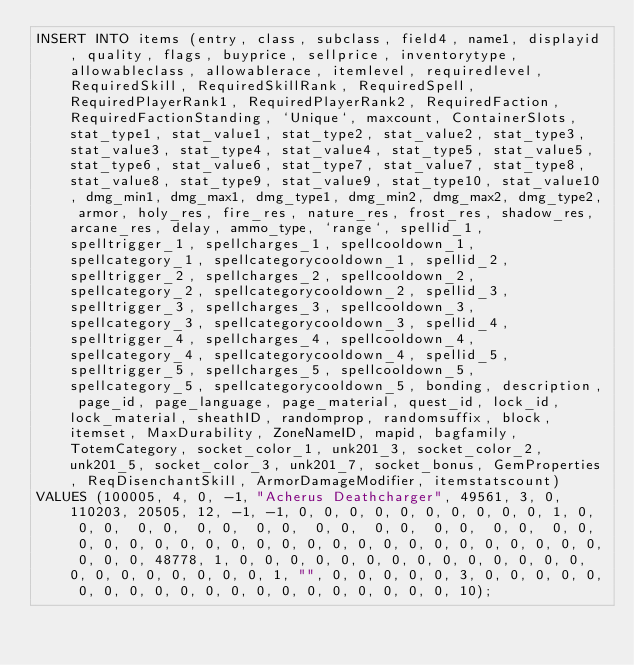<code> <loc_0><loc_0><loc_500><loc_500><_SQL_>INSERT INTO items (entry, class, subclass, field4, name1, displayid, quality, flags, buyprice, sellprice, inventorytype, allowableclass, allowablerace, itemlevel, requiredlevel, RequiredSkill, RequiredSkillRank, RequiredSpell, RequiredPlayerRank1, RequiredPlayerRank2, RequiredFaction, RequiredFactionStanding, `Unique`, maxcount, ContainerSlots, stat_type1, stat_value1, stat_type2, stat_value2, stat_type3, stat_value3, stat_type4, stat_value4, stat_type5, stat_value5, stat_type6, stat_value6, stat_type7, stat_value7, stat_type8, stat_value8, stat_type9, stat_value9, stat_type10, stat_value10, dmg_min1, dmg_max1, dmg_type1, dmg_min2, dmg_max2, dmg_type2, armor, holy_res, fire_res, nature_res, frost_res, shadow_res, arcane_res, delay, ammo_type, `range`, spellid_1, spelltrigger_1, spellcharges_1, spellcooldown_1, spellcategory_1, spellcategorycooldown_1, spellid_2, spelltrigger_2, spellcharges_2, spellcooldown_2, spellcategory_2, spellcategorycooldown_2, spellid_3, spelltrigger_3, spellcharges_3, spellcooldown_3, spellcategory_3, spellcategorycooldown_3, spellid_4, spelltrigger_4, spellcharges_4, spellcooldown_4, spellcategory_4, spellcategorycooldown_4, spellid_5, spelltrigger_5, spellcharges_5, spellcooldown_5, spellcategory_5, spellcategorycooldown_5, bonding, description, page_id, page_language, page_material, quest_id, lock_id, lock_material, sheathID, randomprop, randomsuffix, block, itemset, MaxDurability, ZoneNameID, mapid, bagfamily, TotemCategory, socket_color_1, unk201_3, socket_color_2, unk201_5, socket_color_3, unk201_7, socket_bonus, GemProperties, ReqDisenchantSkill, ArmorDamageModifier, itemstatscount)
VALUES (100005, 4, 0, -1, "Acherus Deathcharger", 49561, 3, 0, 110203, 20505, 12, -1, -1, 0, 0, 0, 0, 0, 0, 0, 0, 0, 0, 1, 0,  0, 0,  0, 0,  0, 0,  0, 0,  0, 0,  0, 0,  0, 0,  0, 0,  0, 0,  0, 0, 0, 0, 0, 0, 0, 0, 0, 0, 0, 0, 0, 0, 0, 0, 0, 0, 0, 0, 0, 0, 0, 0, 48778, 1, 0, 0, 0, 0, 0, 0, 0, 0, 0, 0, 0, 0, 0, 0, 0, 0, 0, 0, 0, 0, 0, 0, 1, "", 0, 0, 0, 0, 0, 3, 0, 0, 0, 0, 0, 0, 0, 0, 0, 0, 0, 0, 0, 0, 0, 0, 0, 0, 0, 0, 10);</code> 